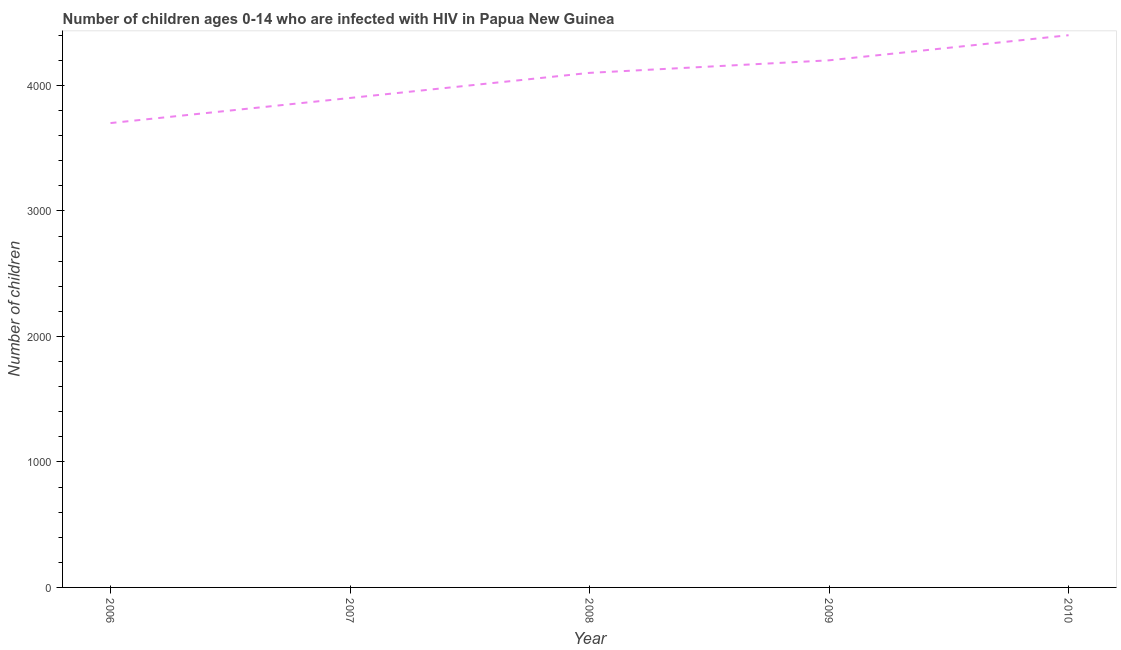What is the number of children living with hiv in 2009?
Your answer should be compact. 4200. Across all years, what is the maximum number of children living with hiv?
Offer a terse response. 4400. Across all years, what is the minimum number of children living with hiv?
Offer a very short reply. 3700. In which year was the number of children living with hiv maximum?
Your response must be concise. 2010. In which year was the number of children living with hiv minimum?
Give a very brief answer. 2006. What is the sum of the number of children living with hiv?
Keep it short and to the point. 2.03e+04. What is the difference between the number of children living with hiv in 2007 and 2009?
Give a very brief answer. -300. What is the average number of children living with hiv per year?
Your answer should be compact. 4060. What is the median number of children living with hiv?
Keep it short and to the point. 4100. In how many years, is the number of children living with hiv greater than 3000 ?
Provide a succinct answer. 5. What is the ratio of the number of children living with hiv in 2006 to that in 2009?
Offer a terse response. 0.88. Is the number of children living with hiv in 2006 less than that in 2007?
Offer a very short reply. Yes. What is the difference between the highest and the lowest number of children living with hiv?
Provide a succinct answer. 700. What is the difference between two consecutive major ticks on the Y-axis?
Offer a very short reply. 1000. Are the values on the major ticks of Y-axis written in scientific E-notation?
Your answer should be compact. No. Does the graph contain grids?
Ensure brevity in your answer.  No. What is the title of the graph?
Keep it short and to the point. Number of children ages 0-14 who are infected with HIV in Papua New Guinea. What is the label or title of the Y-axis?
Ensure brevity in your answer.  Number of children. What is the Number of children of 2006?
Give a very brief answer. 3700. What is the Number of children in 2007?
Your response must be concise. 3900. What is the Number of children in 2008?
Give a very brief answer. 4100. What is the Number of children of 2009?
Provide a succinct answer. 4200. What is the Number of children of 2010?
Offer a very short reply. 4400. What is the difference between the Number of children in 2006 and 2007?
Provide a succinct answer. -200. What is the difference between the Number of children in 2006 and 2008?
Keep it short and to the point. -400. What is the difference between the Number of children in 2006 and 2009?
Your response must be concise. -500. What is the difference between the Number of children in 2006 and 2010?
Your response must be concise. -700. What is the difference between the Number of children in 2007 and 2008?
Offer a very short reply. -200. What is the difference between the Number of children in 2007 and 2009?
Offer a terse response. -300. What is the difference between the Number of children in 2007 and 2010?
Ensure brevity in your answer.  -500. What is the difference between the Number of children in 2008 and 2009?
Offer a terse response. -100. What is the difference between the Number of children in 2008 and 2010?
Give a very brief answer. -300. What is the difference between the Number of children in 2009 and 2010?
Offer a very short reply. -200. What is the ratio of the Number of children in 2006 to that in 2007?
Your answer should be compact. 0.95. What is the ratio of the Number of children in 2006 to that in 2008?
Your answer should be compact. 0.9. What is the ratio of the Number of children in 2006 to that in 2009?
Make the answer very short. 0.88. What is the ratio of the Number of children in 2006 to that in 2010?
Make the answer very short. 0.84. What is the ratio of the Number of children in 2007 to that in 2008?
Offer a terse response. 0.95. What is the ratio of the Number of children in 2007 to that in 2009?
Your answer should be compact. 0.93. What is the ratio of the Number of children in 2007 to that in 2010?
Offer a terse response. 0.89. What is the ratio of the Number of children in 2008 to that in 2010?
Ensure brevity in your answer.  0.93. What is the ratio of the Number of children in 2009 to that in 2010?
Your response must be concise. 0.95. 